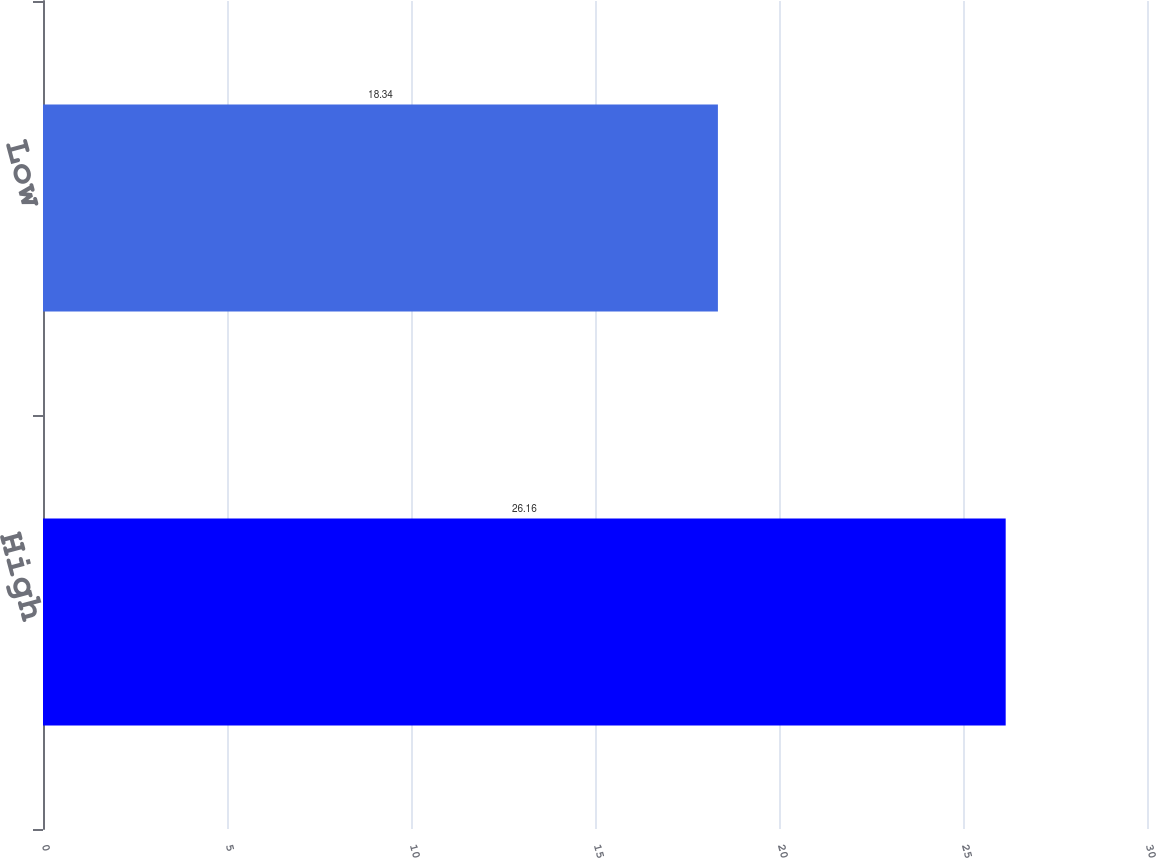Convert chart. <chart><loc_0><loc_0><loc_500><loc_500><bar_chart><fcel>High<fcel>Low<nl><fcel>26.16<fcel>18.34<nl></chart> 